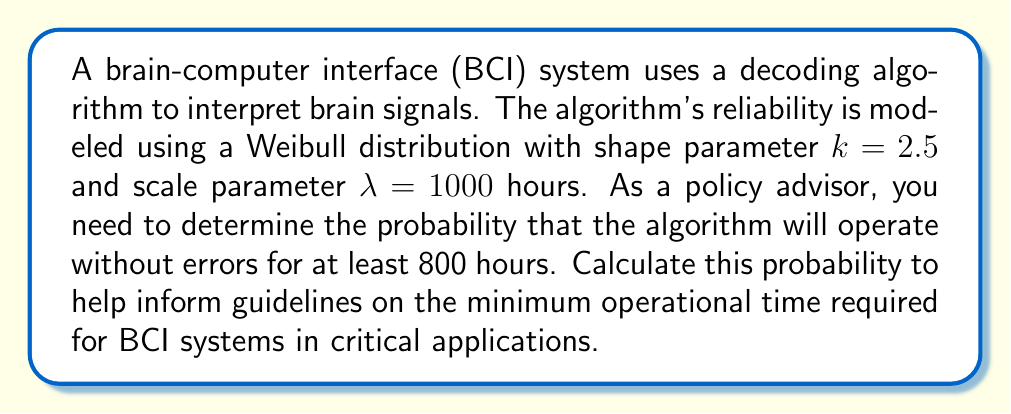Can you answer this question? To solve this problem, we'll use the reliability function (also known as the survival function) of the Weibull distribution. The steps are as follows:

1) The reliability function for a Weibull distribution is given by:

   $$R(t) = e^{-(\frac{t}{\lambda})^k}$$

   where $t$ is the time, $k$ is the shape parameter, and $\lambda$ is the scale parameter.

2) We're given:
   $k = 2.5$
   $\lambda = 1000$ hours
   $t = 800$ hours

3) Substituting these values into the reliability function:

   $$R(800) = e^{-(\frac{800}{1000})^{2.5}}$$

4) Simplify the fraction inside the parentheses:

   $$R(800) = e^{-(0.8)^{2.5}}$$

5) Calculate the exponent:

   $$R(800) = e^{-(0.8)^{2.5}} = e^{-0.5724}$$

6) Calculate the final value:

   $$R(800) = 0.5641$$

Therefore, the probability that the algorithm will operate without errors for at least 800 hours is approximately 0.5641 or 56.41%.
Answer: 0.5641 